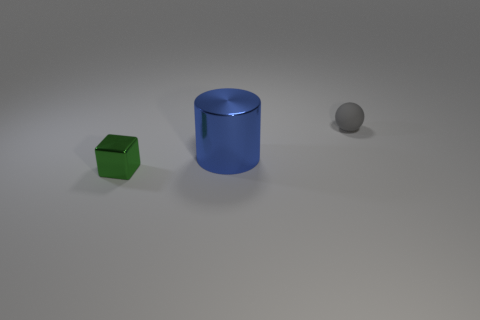There is a object that is to the right of the blue metallic cylinder; what color is it?
Offer a very short reply. Gray. Is the shape of the tiny gray matte thing the same as the big thing?
Keep it short and to the point. No. The object that is both right of the green object and in front of the gray object is what color?
Provide a succinct answer. Blue. There is a metallic thing behind the tiny shiny thing; is it the same size as the object to the right of the blue thing?
Your answer should be very brief. No. What number of objects are objects to the right of the large blue object or tiny balls?
Make the answer very short. 1. What material is the cylinder?
Your response must be concise. Metal. Is the gray rubber thing the same size as the blue metal thing?
Offer a very short reply. No. How many cylinders are big things or tiny gray matte objects?
Keep it short and to the point. 1. What color is the metal thing behind the tiny thing in front of the small gray rubber ball?
Make the answer very short. Blue. Is the number of matte balls on the left side of the matte sphere less than the number of green cubes right of the metal cylinder?
Your answer should be very brief. No. 